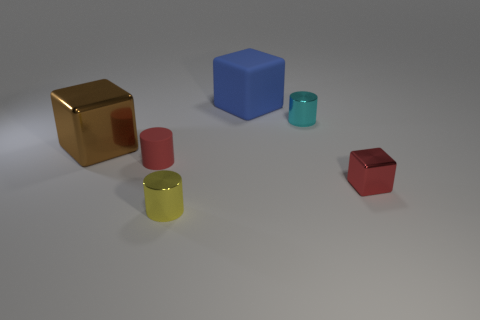Are there any cyan shiny things of the same size as the yellow cylinder?
Your answer should be very brief. Yes. Are there the same number of blue cubes that are on the right side of the cyan cylinder and tiny cubes that are to the left of the large brown metal cube?
Your answer should be very brief. Yes. Are the large object that is right of the large brown cube and the large object that is in front of the cyan object made of the same material?
Offer a very short reply. No. What material is the tiny yellow object?
Your answer should be very brief. Metal. How many other objects are the same color as the big matte cube?
Your answer should be compact. 0. Do the large metal object and the rubber cube have the same color?
Offer a very short reply. No. What number of cyan spheres are there?
Give a very brief answer. 0. What material is the cube left of the small shiny cylinder in front of the brown thing made of?
Provide a short and direct response. Metal. What material is the cyan object that is the same size as the red metal thing?
Your answer should be very brief. Metal. There is a rubber thing that is to the left of the blue block; is its size the same as the small block?
Provide a succinct answer. Yes. 